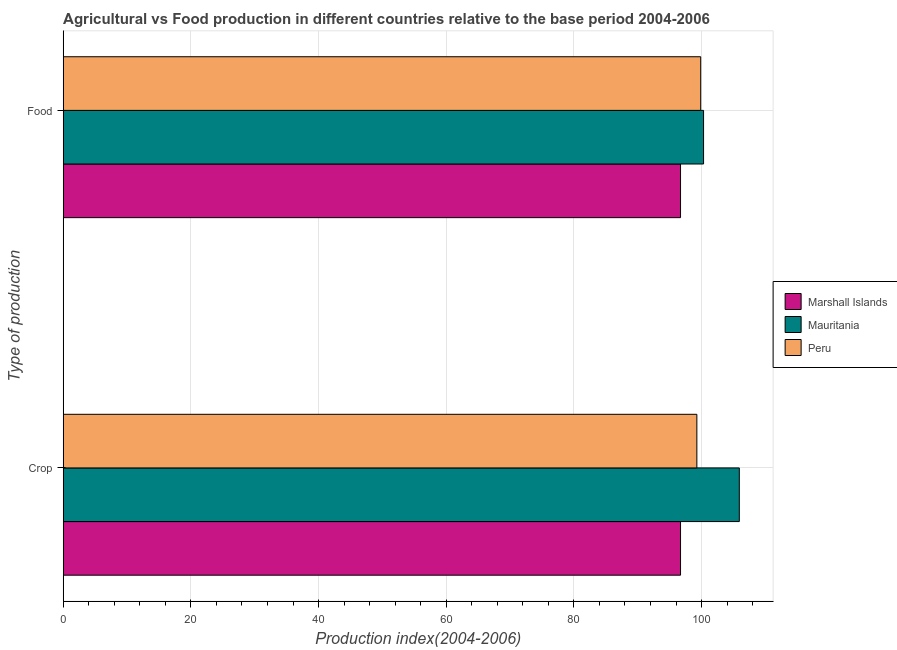How many groups of bars are there?
Keep it short and to the point. 2. Are the number of bars on each tick of the Y-axis equal?
Offer a terse response. Yes. How many bars are there on the 1st tick from the bottom?
Provide a short and direct response. 3. What is the label of the 2nd group of bars from the top?
Your response must be concise. Crop. What is the food production index in Marshall Islands?
Your answer should be very brief. 96.71. Across all countries, what is the maximum food production index?
Make the answer very short. 100.32. Across all countries, what is the minimum food production index?
Offer a very short reply. 96.71. In which country was the food production index maximum?
Your answer should be very brief. Mauritania. In which country was the crop production index minimum?
Your answer should be very brief. Marshall Islands. What is the total food production index in the graph?
Provide a succinct answer. 296.9. What is the difference between the food production index in Peru and that in Mauritania?
Offer a very short reply. -0.45. What is the difference between the food production index in Marshall Islands and the crop production index in Peru?
Your answer should be compact. -2.56. What is the average crop production index per country?
Your answer should be compact. 100.63. What is the ratio of the food production index in Peru to that in Marshall Islands?
Your answer should be very brief. 1.03. Is the food production index in Mauritania less than that in Marshall Islands?
Make the answer very short. No. In how many countries, is the crop production index greater than the average crop production index taken over all countries?
Give a very brief answer. 1. What does the 1st bar from the top in Food represents?
Keep it short and to the point. Peru. What does the 1st bar from the bottom in Crop represents?
Provide a succinct answer. Marshall Islands. How many bars are there?
Keep it short and to the point. 6. Are all the bars in the graph horizontal?
Make the answer very short. Yes. Are the values on the major ticks of X-axis written in scientific E-notation?
Offer a very short reply. No. Does the graph contain any zero values?
Provide a short and direct response. No. How are the legend labels stacked?
Your answer should be compact. Vertical. What is the title of the graph?
Your answer should be very brief. Agricultural vs Food production in different countries relative to the base period 2004-2006. Does "Switzerland" appear as one of the legend labels in the graph?
Provide a short and direct response. No. What is the label or title of the X-axis?
Ensure brevity in your answer.  Production index(2004-2006). What is the label or title of the Y-axis?
Keep it short and to the point. Type of production. What is the Production index(2004-2006) of Marshall Islands in Crop?
Provide a short and direct response. 96.71. What is the Production index(2004-2006) in Mauritania in Crop?
Provide a short and direct response. 105.92. What is the Production index(2004-2006) of Peru in Crop?
Provide a short and direct response. 99.27. What is the Production index(2004-2006) in Marshall Islands in Food?
Give a very brief answer. 96.71. What is the Production index(2004-2006) in Mauritania in Food?
Your answer should be compact. 100.32. What is the Production index(2004-2006) in Peru in Food?
Your answer should be compact. 99.87. Across all Type of production, what is the maximum Production index(2004-2006) in Marshall Islands?
Make the answer very short. 96.71. Across all Type of production, what is the maximum Production index(2004-2006) of Mauritania?
Offer a terse response. 105.92. Across all Type of production, what is the maximum Production index(2004-2006) of Peru?
Ensure brevity in your answer.  99.87. Across all Type of production, what is the minimum Production index(2004-2006) in Marshall Islands?
Give a very brief answer. 96.71. Across all Type of production, what is the minimum Production index(2004-2006) in Mauritania?
Offer a very short reply. 100.32. Across all Type of production, what is the minimum Production index(2004-2006) in Peru?
Provide a short and direct response. 99.27. What is the total Production index(2004-2006) in Marshall Islands in the graph?
Offer a very short reply. 193.42. What is the total Production index(2004-2006) of Mauritania in the graph?
Keep it short and to the point. 206.24. What is the total Production index(2004-2006) of Peru in the graph?
Give a very brief answer. 199.14. What is the difference between the Production index(2004-2006) of Marshall Islands in Crop and the Production index(2004-2006) of Mauritania in Food?
Your response must be concise. -3.61. What is the difference between the Production index(2004-2006) of Marshall Islands in Crop and the Production index(2004-2006) of Peru in Food?
Make the answer very short. -3.16. What is the difference between the Production index(2004-2006) in Mauritania in Crop and the Production index(2004-2006) in Peru in Food?
Provide a succinct answer. 6.05. What is the average Production index(2004-2006) in Marshall Islands per Type of production?
Ensure brevity in your answer.  96.71. What is the average Production index(2004-2006) of Mauritania per Type of production?
Your answer should be very brief. 103.12. What is the average Production index(2004-2006) of Peru per Type of production?
Your answer should be very brief. 99.57. What is the difference between the Production index(2004-2006) of Marshall Islands and Production index(2004-2006) of Mauritania in Crop?
Ensure brevity in your answer.  -9.21. What is the difference between the Production index(2004-2006) of Marshall Islands and Production index(2004-2006) of Peru in Crop?
Your response must be concise. -2.56. What is the difference between the Production index(2004-2006) of Mauritania and Production index(2004-2006) of Peru in Crop?
Give a very brief answer. 6.65. What is the difference between the Production index(2004-2006) in Marshall Islands and Production index(2004-2006) in Mauritania in Food?
Make the answer very short. -3.61. What is the difference between the Production index(2004-2006) of Marshall Islands and Production index(2004-2006) of Peru in Food?
Your response must be concise. -3.16. What is the difference between the Production index(2004-2006) in Mauritania and Production index(2004-2006) in Peru in Food?
Provide a succinct answer. 0.45. What is the ratio of the Production index(2004-2006) in Mauritania in Crop to that in Food?
Make the answer very short. 1.06. What is the difference between the highest and the second highest Production index(2004-2006) in Marshall Islands?
Keep it short and to the point. 0. What is the difference between the highest and the second highest Production index(2004-2006) of Mauritania?
Offer a very short reply. 5.6. What is the difference between the highest and the second highest Production index(2004-2006) of Peru?
Provide a succinct answer. 0.6. What is the difference between the highest and the lowest Production index(2004-2006) in Marshall Islands?
Ensure brevity in your answer.  0. What is the difference between the highest and the lowest Production index(2004-2006) in Peru?
Ensure brevity in your answer.  0.6. 